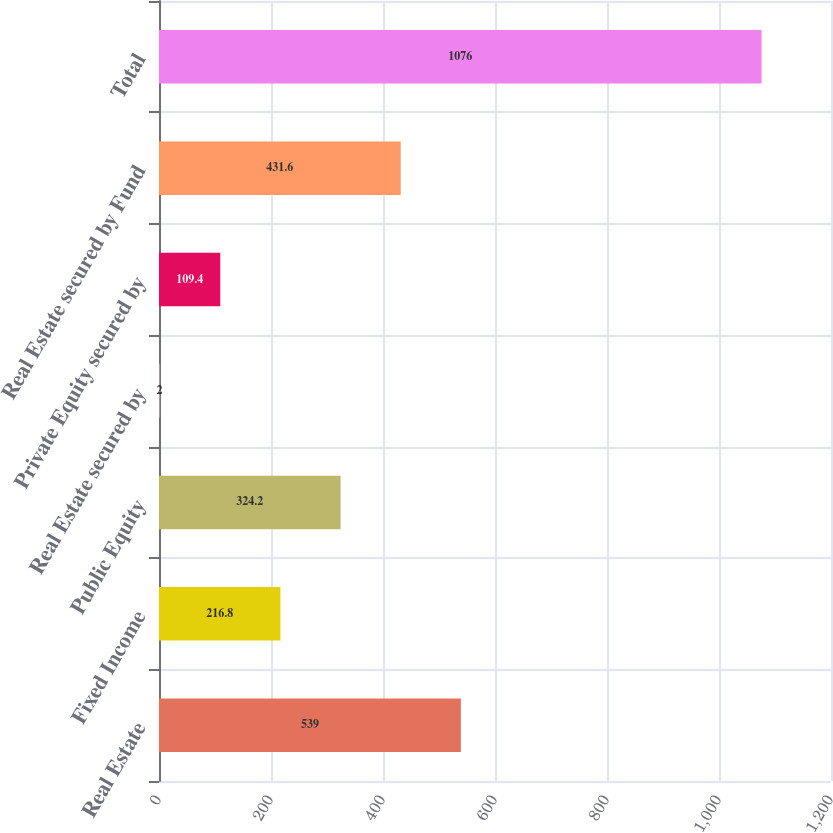<chart> <loc_0><loc_0><loc_500><loc_500><bar_chart><fcel>Real Estate<fcel>Fixed Income<fcel>Public Equity<fcel>Real Estate secured by<fcel>Private Equity secured by<fcel>Real Estate secured by Fund<fcel>Total<nl><fcel>539<fcel>216.8<fcel>324.2<fcel>2<fcel>109.4<fcel>431.6<fcel>1076<nl></chart> 